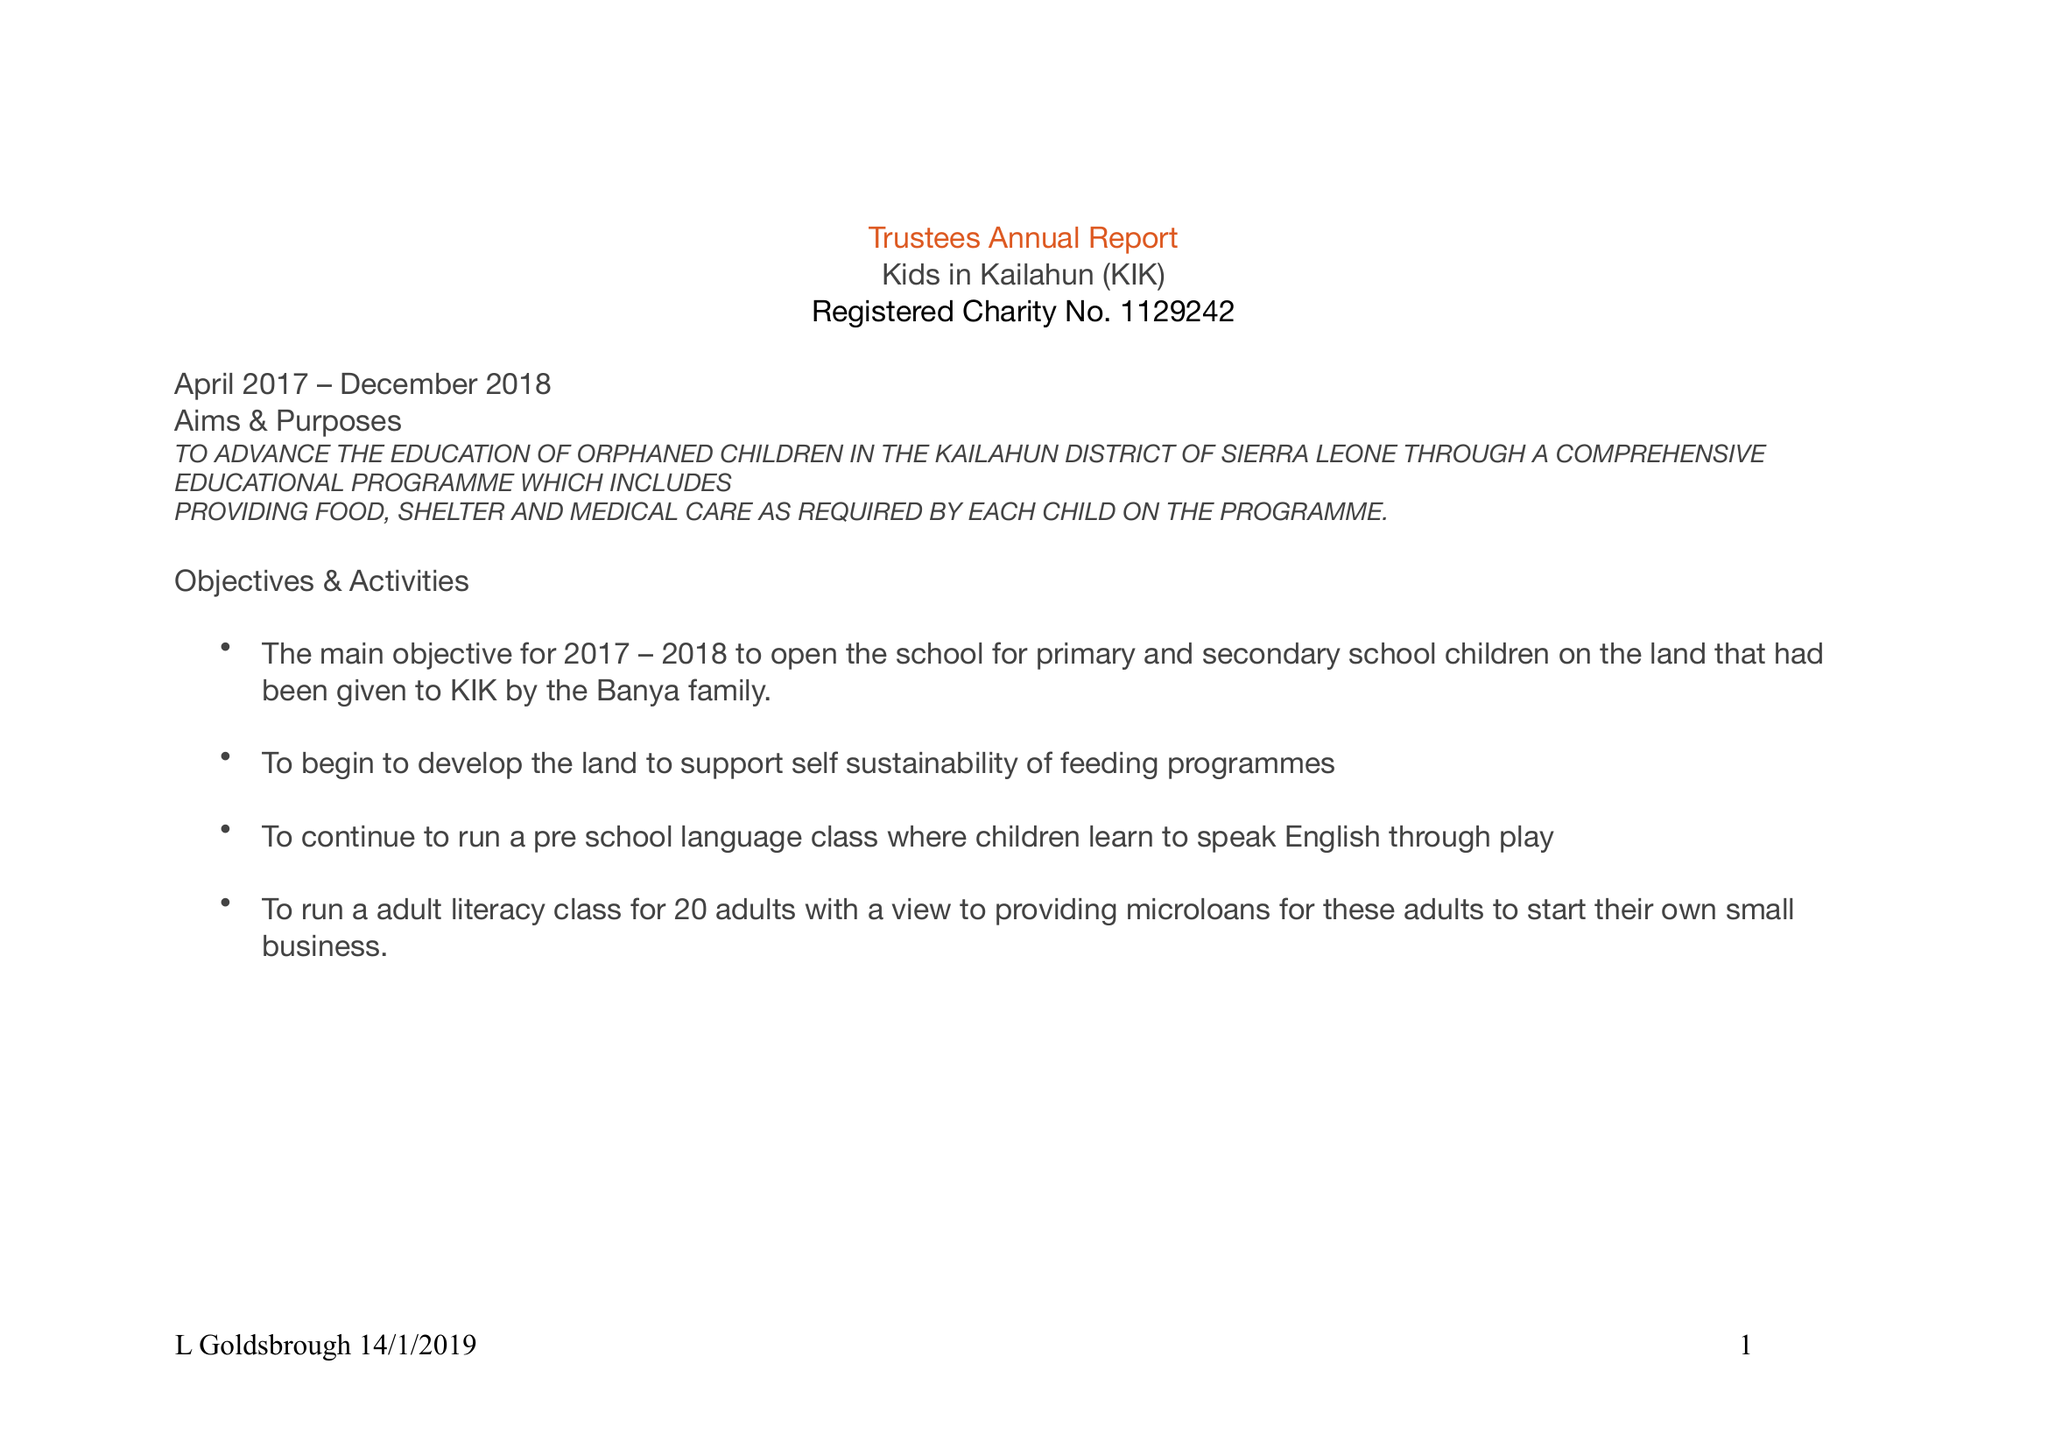What is the value for the address__post_town?
Answer the question using a single word or phrase. BURNLEY 